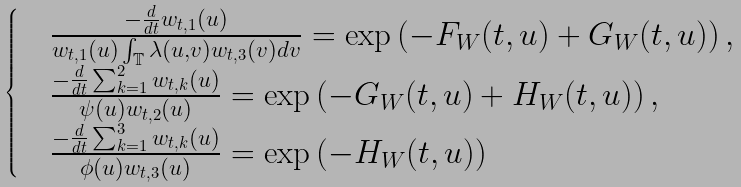<formula> <loc_0><loc_0><loc_500><loc_500>\begin{cases} & \frac { - \frac { d } { d t } w _ { t , 1 } ( u ) } { w _ { t , 1 } ( u ) \int _ { \mathbb { T } } \lambda ( u , v ) w _ { t , 3 } ( v ) d v } = \exp \left ( - F _ { W } ( t , u ) + G _ { W } ( t , u ) \right ) , \\ & \frac { - \frac { d } { d t } \sum _ { k = 1 } ^ { 2 } w _ { t , k } ( u ) } { \psi ( u ) w _ { t , 2 } ( u ) } = \exp \left ( - G _ { W } ( t , u ) + H _ { W } ( t , u ) \right ) , \\ & \frac { - \frac { d } { d t } \sum _ { k = 1 } ^ { 3 } w _ { t , k } ( u ) } { \phi ( u ) w _ { t , 3 } ( u ) } = \exp \left ( - H _ { W } ( t , u ) \right ) \end{cases}</formula> 